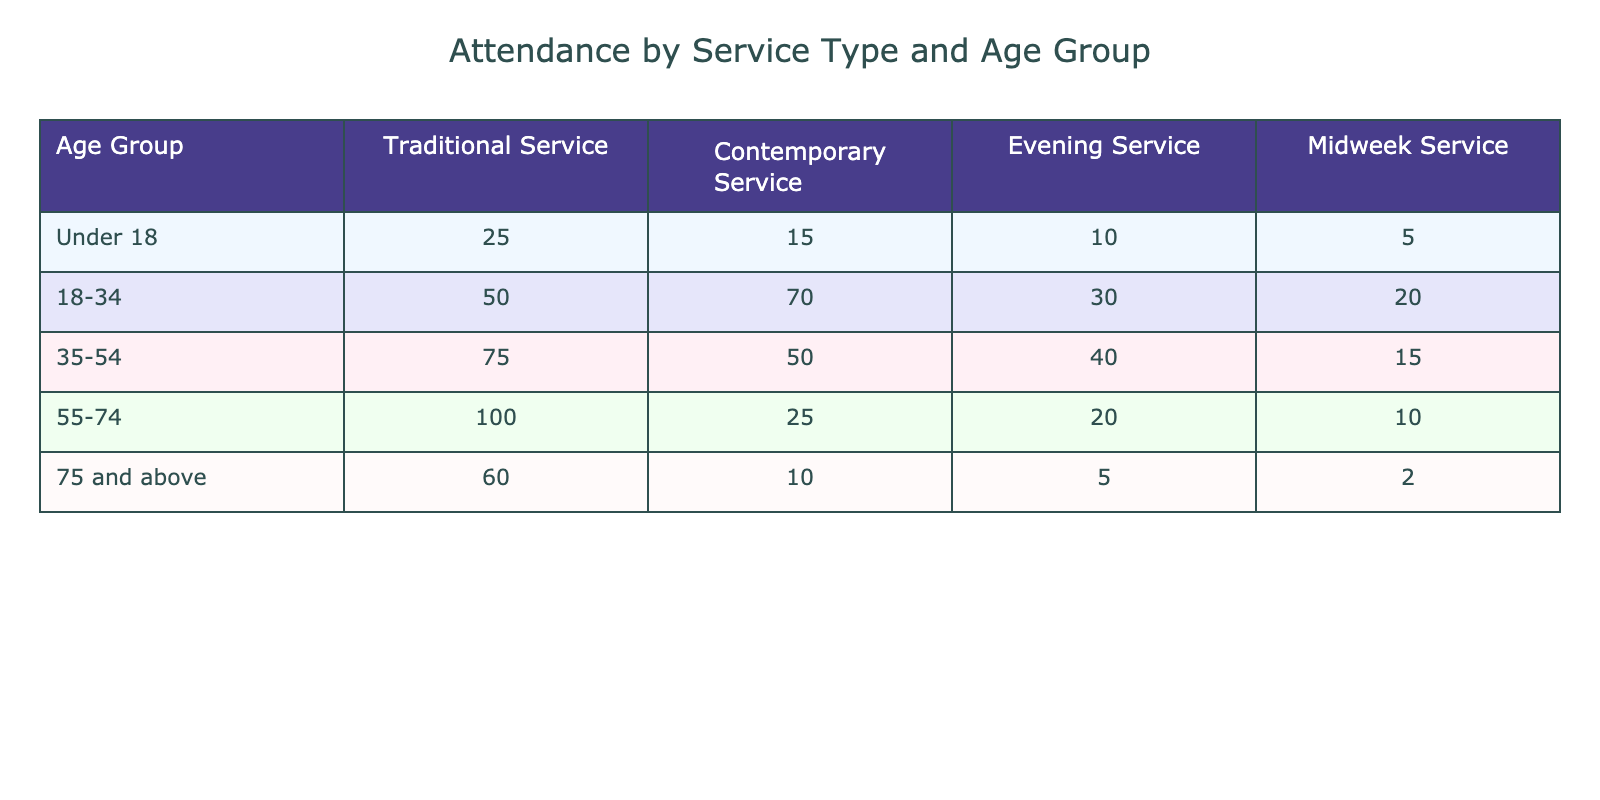What is the total attendance for the Traditional Service across all age groups? To find the total attendance for the Traditional Service, I will sum the values from that column: 25 + 50 + 75 + 100 + 60 = 310.
Answer: 310 Which age group has the highest attendance for the Contemporary Service? Looking at the Contemporary Service column, the highest value is 70, which corresponds to the age group 18-34.
Answer: 18-34 Is the attendance for the Evening Service greater for the 35-54 age group than for the 55-74 age group? The attendance for the 35-54 age group in the Evening Service is 40, while for the 55-74 age group, it is 20. Since 40 is greater than 20, the statement is true.
Answer: Yes What is the average attendance for all age groups in the Midweek Service? I will add the values for the Midweek Service: 5 + 20 + 15 + 10 + 2 = 52. There are 5 age groups, so the average is 52 / 5 = 10.4.
Answer: 10.4 Is it true that adults aged 55 and above have higher overall attendance in Traditional and Contemporary Services than those aged 18-34? The total attendance for 55 and above in the Traditional Service is 100 + 60 = 160, and for Contemporary Service, it is 25 + 10 = 35, giving a total of 195. For 18-34, the attendance is 50 + 70 = 120. Since 195 is greater than 120, the statement is true.
Answer: Yes Which age group has the lowest total attendance across all services? To find the age group with the lowest total attendance, I will calculate the total for each age group: Under 18: 25 + 15 + 10 + 5 = 55; 18-34: 50 + 70 + 30 + 20 = 170; 35-54: 75 + 50 + 40 + 15 = 180; 55-74: 100 + 25 + 20 + 10 = 155; 75 and above: 60 + 10 + 5 + 2 = 77. The lowest is 55 for Under 18.
Answer: Under 18 How many people in the 75 and above age group attend the Traditional Service compared to the Contemporary Service? In the Traditional Service, 60 people attend the 75 and above age group, and in the Contemporary Service, 10 people attend. Comparing these figures, 60 is greater than 10.
Answer: 60 attend Traditional, 10 attend Contemporary What is the difference in attendance between the 35-54 age group for Traditional Service and Evening Service? For the 35-54 age group, the attendance in the Traditional Service is 75 and in the Evening Service is 40. The difference is 75 - 40 = 35.
Answer: 35 If we were to combine the attendance from the Traditional and Contemporary Services for those aged under 18, what would that total be? The attendance for the Traditional Service for those under 18 is 25 and for the Contemporary Service, it is 15. Therefore, the total is 25 + 15 = 40.
Answer: 40 